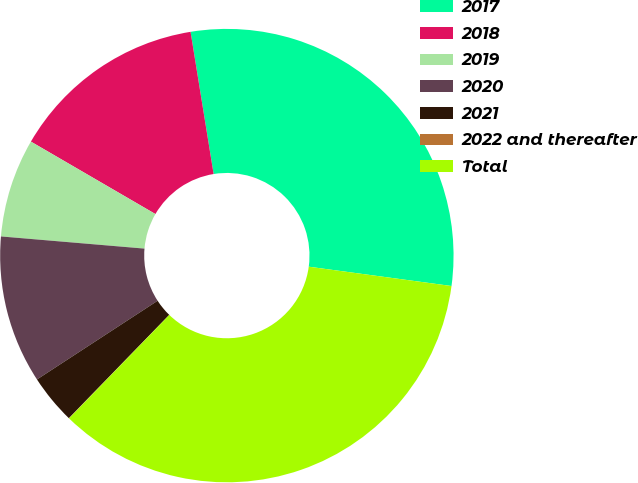<chart> <loc_0><loc_0><loc_500><loc_500><pie_chart><fcel>2017<fcel>2018<fcel>2019<fcel>2020<fcel>2021<fcel>2022 and thereafter<fcel>Total<nl><fcel>29.71%<fcel>14.06%<fcel>7.04%<fcel>10.55%<fcel>3.53%<fcel>0.02%<fcel>35.12%<nl></chart> 